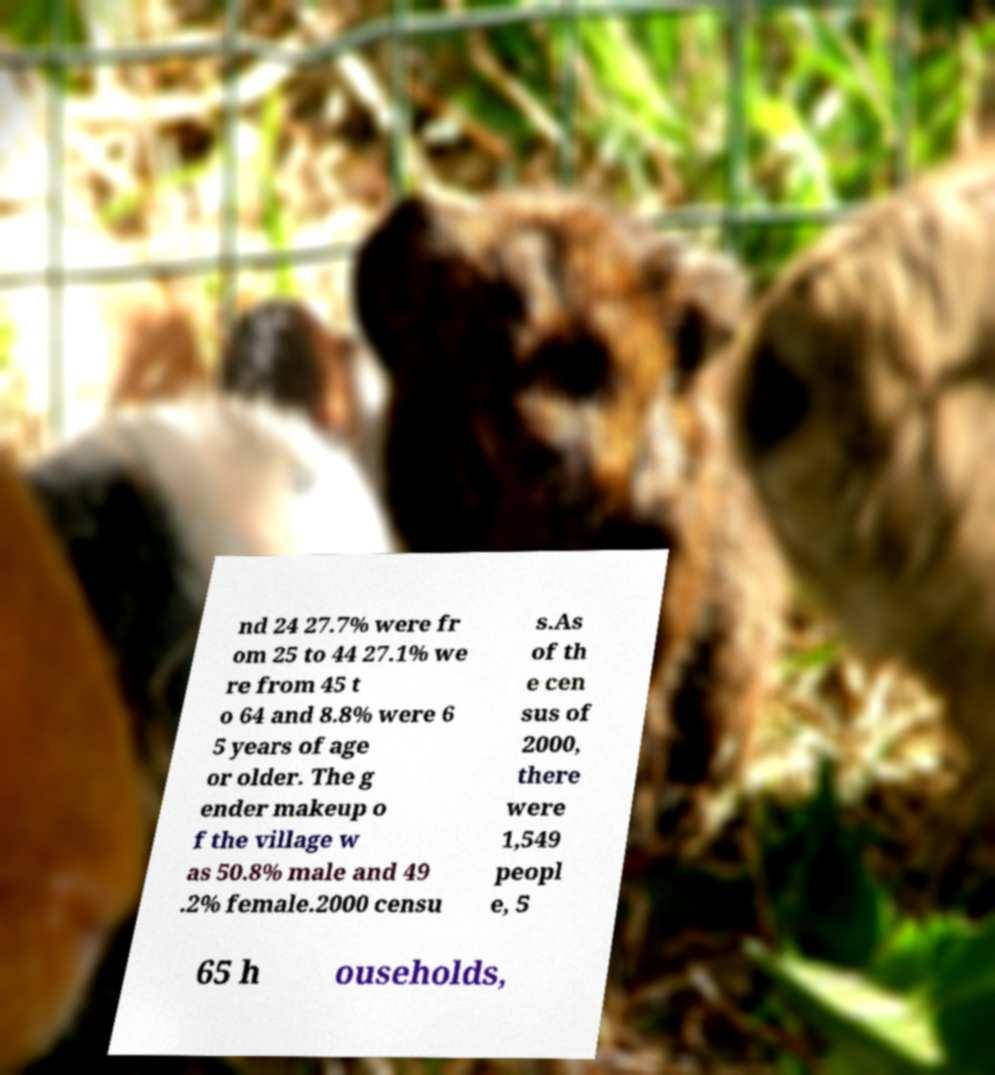Can you accurately transcribe the text from the provided image for me? nd 24 27.7% were fr om 25 to 44 27.1% we re from 45 t o 64 and 8.8% were 6 5 years of age or older. The g ender makeup o f the village w as 50.8% male and 49 .2% female.2000 censu s.As of th e cen sus of 2000, there were 1,549 peopl e, 5 65 h ouseholds, 